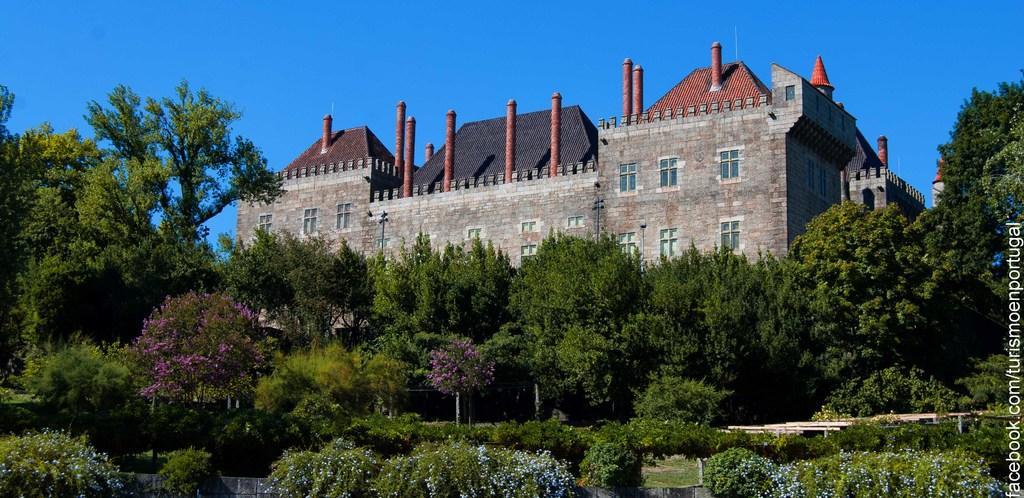How would you summarize this image in a sentence or two? In the picture I can see shrubs, trees, stone building and the blue color sky in the background. Here I can see the watermark at the right side corner of the image. 